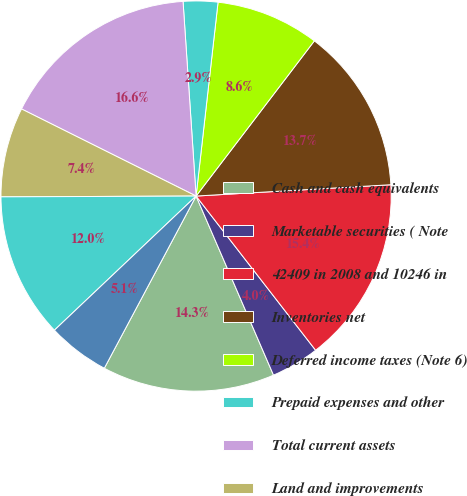Convert chart. <chart><loc_0><loc_0><loc_500><loc_500><pie_chart><fcel>Cash and cash equivalents<fcel>Marketable securities ( Note<fcel>42409 in 2008 and 10246 in<fcel>Inventories net<fcel>Deferred income taxes (Note 6)<fcel>Prepaid expenses and other<fcel>Total current assets<fcel>Land and improvements<fcel>Building and improvements<fcel>Office furniture and equipment<nl><fcel>14.29%<fcel>4.0%<fcel>15.43%<fcel>13.71%<fcel>8.57%<fcel>2.86%<fcel>16.57%<fcel>7.43%<fcel>12.0%<fcel>5.14%<nl></chart> 